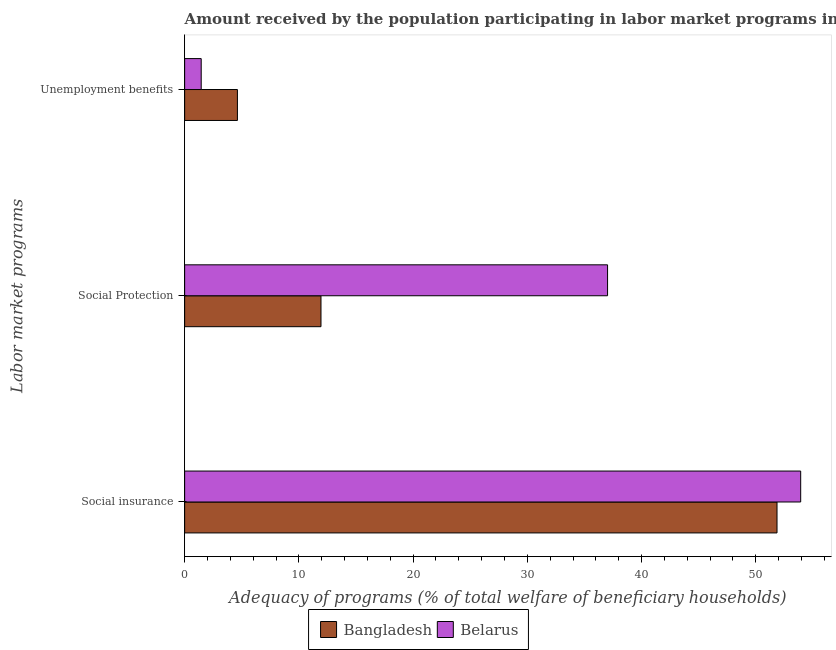How many different coloured bars are there?
Your answer should be very brief. 2. How many groups of bars are there?
Your answer should be compact. 3. Are the number of bars per tick equal to the number of legend labels?
Give a very brief answer. Yes. How many bars are there on the 2nd tick from the bottom?
Your answer should be very brief. 2. What is the label of the 3rd group of bars from the top?
Offer a terse response. Social insurance. What is the amount received by the population participating in unemployment benefits programs in Bangladesh?
Keep it short and to the point. 4.62. Across all countries, what is the maximum amount received by the population participating in social insurance programs?
Give a very brief answer. 53.93. Across all countries, what is the minimum amount received by the population participating in social insurance programs?
Give a very brief answer. 51.86. In which country was the amount received by the population participating in social protection programs maximum?
Your answer should be very brief. Belarus. What is the total amount received by the population participating in unemployment benefits programs in the graph?
Keep it short and to the point. 6.07. What is the difference between the amount received by the population participating in unemployment benefits programs in Bangladesh and that in Belarus?
Your answer should be very brief. 3.17. What is the difference between the amount received by the population participating in social protection programs in Belarus and the amount received by the population participating in unemployment benefits programs in Bangladesh?
Give a very brief answer. 32.41. What is the average amount received by the population participating in unemployment benefits programs per country?
Ensure brevity in your answer.  3.04. What is the difference between the amount received by the population participating in unemployment benefits programs and amount received by the population participating in social insurance programs in Bangladesh?
Your response must be concise. -47.24. What is the ratio of the amount received by the population participating in social insurance programs in Belarus to that in Bangladesh?
Give a very brief answer. 1.04. What is the difference between the highest and the second highest amount received by the population participating in social insurance programs?
Offer a terse response. 2.07. What is the difference between the highest and the lowest amount received by the population participating in social protection programs?
Make the answer very short. 25.09. In how many countries, is the amount received by the population participating in social insurance programs greater than the average amount received by the population participating in social insurance programs taken over all countries?
Provide a short and direct response. 1. Is the sum of the amount received by the population participating in unemployment benefits programs in Bangladesh and Belarus greater than the maximum amount received by the population participating in social insurance programs across all countries?
Ensure brevity in your answer.  No. How many bars are there?
Keep it short and to the point. 6. Are all the bars in the graph horizontal?
Give a very brief answer. Yes. How many countries are there in the graph?
Your answer should be very brief. 2. What is the difference between two consecutive major ticks on the X-axis?
Provide a short and direct response. 10. Are the values on the major ticks of X-axis written in scientific E-notation?
Provide a short and direct response. No. Does the graph contain any zero values?
Make the answer very short. No. What is the title of the graph?
Offer a terse response. Amount received by the population participating in labor market programs in countries. Does "United Arab Emirates" appear as one of the legend labels in the graph?
Your answer should be compact. No. What is the label or title of the X-axis?
Give a very brief answer. Adequacy of programs (% of total welfare of beneficiary households). What is the label or title of the Y-axis?
Your answer should be very brief. Labor market programs. What is the Adequacy of programs (% of total welfare of beneficiary households) in Bangladesh in Social insurance?
Offer a very short reply. 51.86. What is the Adequacy of programs (% of total welfare of beneficiary households) in Belarus in Social insurance?
Offer a very short reply. 53.93. What is the Adequacy of programs (% of total welfare of beneficiary households) of Bangladesh in Social Protection?
Give a very brief answer. 11.94. What is the Adequacy of programs (% of total welfare of beneficiary households) of Belarus in Social Protection?
Your answer should be very brief. 37.03. What is the Adequacy of programs (% of total welfare of beneficiary households) in Bangladesh in Unemployment benefits?
Make the answer very short. 4.62. What is the Adequacy of programs (% of total welfare of beneficiary households) of Belarus in Unemployment benefits?
Offer a very short reply. 1.45. Across all Labor market programs, what is the maximum Adequacy of programs (% of total welfare of beneficiary households) of Bangladesh?
Your answer should be very brief. 51.86. Across all Labor market programs, what is the maximum Adequacy of programs (% of total welfare of beneficiary households) of Belarus?
Your answer should be compact. 53.93. Across all Labor market programs, what is the minimum Adequacy of programs (% of total welfare of beneficiary households) in Bangladesh?
Make the answer very short. 4.62. Across all Labor market programs, what is the minimum Adequacy of programs (% of total welfare of beneficiary households) of Belarus?
Offer a terse response. 1.45. What is the total Adequacy of programs (% of total welfare of beneficiary households) of Bangladesh in the graph?
Your answer should be very brief. 68.42. What is the total Adequacy of programs (% of total welfare of beneficiary households) of Belarus in the graph?
Give a very brief answer. 92.41. What is the difference between the Adequacy of programs (% of total welfare of beneficiary households) of Bangladesh in Social insurance and that in Social Protection?
Keep it short and to the point. 39.92. What is the difference between the Adequacy of programs (% of total welfare of beneficiary households) of Belarus in Social insurance and that in Social Protection?
Keep it short and to the point. 16.91. What is the difference between the Adequacy of programs (% of total welfare of beneficiary households) in Bangladesh in Social insurance and that in Unemployment benefits?
Offer a very short reply. 47.24. What is the difference between the Adequacy of programs (% of total welfare of beneficiary households) of Belarus in Social insurance and that in Unemployment benefits?
Your answer should be compact. 52.48. What is the difference between the Adequacy of programs (% of total welfare of beneficiary households) of Bangladesh in Social Protection and that in Unemployment benefits?
Keep it short and to the point. 7.32. What is the difference between the Adequacy of programs (% of total welfare of beneficiary households) in Belarus in Social Protection and that in Unemployment benefits?
Offer a terse response. 35.58. What is the difference between the Adequacy of programs (% of total welfare of beneficiary households) of Bangladesh in Social insurance and the Adequacy of programs (% of total welfare of beneficiary households) of Belarus in Social Protection?
Your response must be concise. 14.84. What is the difference between the Adequacy of programs (% of total welfare of beneficiary households) in Bangladesh in Social insurance and the Adequacy of programs (% of total welfare of beneficiary households) in Belarus in Unemployment benefits?
Ensure brevity in your answer.  50.41. What is the difference between the Adequacy of programs (% of total welfare of beneficiary households) of Bangladesh in Social Protection and the Adequacy of programs (% of total welfare of beneficiary households) of Belarus in Unemployment benefits?
Keep it short and to the point. 10.49. What is the average Adequacy of programs (% of total welfare of beneficiary households) of Bangladesh per Labor market programs?
Offer a terse response. 22.81. What is the average Adequacy of programs (% of total welfare of beneficiary households) in Belarus per Labor market programs?
Offer a terse response. 30.8. What is the difference between the Adequacy of programs (% of total welfare of beneficiary households) of Bangladesh and Adequacy of programs (% of total welfare of beneficiary households) of Belarus in Social insurance?
Offer a very short reply. -2.07. What is the difference between the Adequacy of programs (% of total welfare of beneficiary households) of Bangladesh and Adequacy of programs (% of total welfare of beneficiary households) of Belarus in Social Protection?
Ensure brevity in your answer.  -25.09. What is the difference between the Adequacy of programs (% of total welfare of beneficiary households) in Bangladesh and Adequacy of programs (% of total welfare of beneficiary households) in Belarus in Unemployment benefits?
Offer a terse response. 3.17. What is the ratio of the Adequacy of programs (% of total welfare of beneficiary households) of Bangladesh in Social insurance to that in Social Protection?
Offer a very short reply. 4.34. What is the ratio of the Adequacy of programs (% of total welfare of beneficiary households) in Belarus in Social insurance to that in Social Protection?
Provide a succinct answer. 1.46. What is the ratio of the Adequacy of programs (% of total welfare of beneficiary households) of Bangladesh in Social insurance to that in Unemployment benefits?
Provide a short and direct response. 11.22. What is the ratio of the Adequacy of programs (% of total welfare of beneficiary households) in Belarus in Social insurance to that in Unemployment benefits?
Ensure brevity in your answer.  37.19. What is the ratio of the Adequacy of programs (% of total welfare of beneficiary households) of Bangladesh in Social Protection to that in Unemployment benefits?
Give a very brief answer. 2.58. What is the ratio of the Adequacy of programs (% of total welfare of beneficiary households) of Belarus in Social Protection to that in Unemployment benefits?
Give a very brief answer. 25.53. What is the difference between the highest and the second highest Adequacy of programs (% of total welfare of beneficiary households) of Bangladesh?
Give a very brief answer. 39.92. What is the difference between the highest and the second highest Adequacy of programs (% of total welfare of beneficiary households) of Belarus?
Keep it short and to the point. 16.91. What is the difference between the highest and the lowest Adequacy of programs (% of total welfare of beneficiary households) of Bangladesh?
Ensure brevity in your answer.  47.24. What is the difference between the highest and the lowest Adequacy of programs (% of total welfare of beneficiary households) of Belarus?
Offer a terse response. 52.48. 